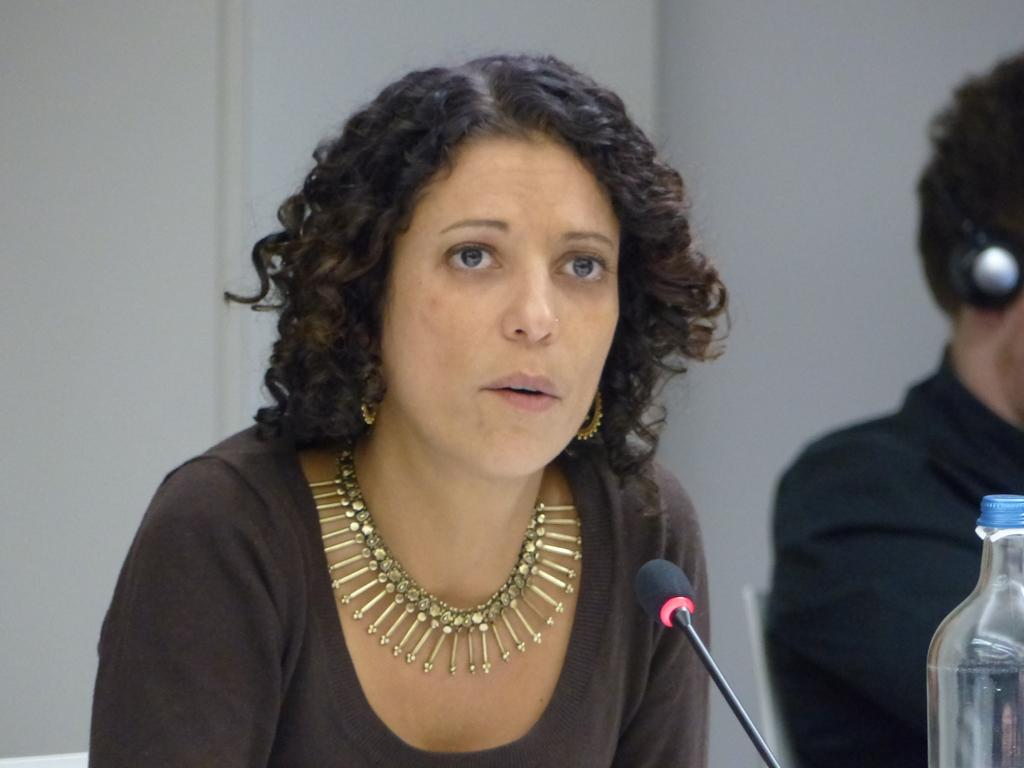Who is the main subject in the image? There is a woman in the image. What is the woman doing in the image? The woman is talking on a microphone. Are there any other people in the image? Yes, there is a man in the image. What can be seen on the right side of the image? There is a bottle on the right side of the image. What color is the bird's shirt in the image? There is no bird or shirt present in the image. 